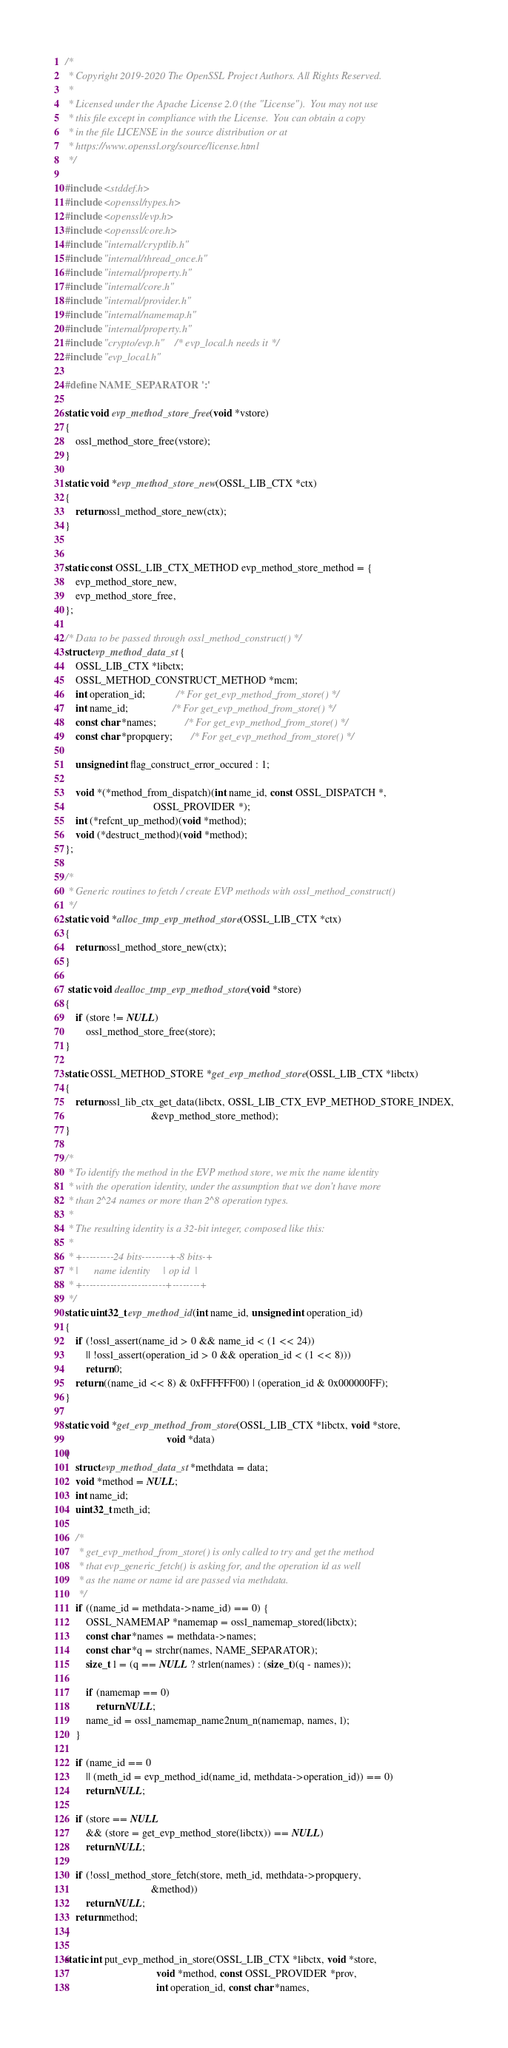Convert code to text. <code><loc_0><loc_0><loc_500><loc_500><_C_>/*
 * Copyright 2019-2020 The OpenSSL Project Authors. All Rights Reserved.
 *
 * Licensed under the Apache License 2.0 (the "License").  You may not use
 * this file except in compliance with the License.  You can obtain a copy
 * in the file LICENSE in the source distribution or at
 * https://www.openssl.org/source/license.html
 */

#include <stddef.h>
#include <openssl/types.h>
#include <openssl/evp.h>
#include <openssl/core.h>
#include "internal/cryptlib.h"
#include "internal/thread_once.h"
#include "internal/property.h"
#include "internal/core.h"
#include "internal/provider.h"
#include "internal/namemap.h"
#include "internal/property.h"
#include "crypto/evp.h"    /* evp_local.h needs it */
#include "evp_local.h"

#define NAME_SEPARATOR ':'

static void evp_method_store_free(void *vstore)
{
    ossl_method_store_free(vstore);
}

static void *evp_method_store_new(OSSL_LIB_CTX *ctx)
{
    return ossl_method_store_new(ctx);
}


static const OSSL_LIB_CTX_METHOD evp_method_store_method = {
    evp_method_store_new,
    evp_method_store_free,
};

/* Data to be passed through ossl_method_construct() */
struct evp_method_data_st {
    OSSL_LIB_CTX *libctx;
    OSSL_METHOD_CONSTRUCT_METHOD *mcm;
    int operation_id;            /* For get_evp_method_from_store() */
    int name_id;                 /* For get_evp_method_from_store() */
    const char *names;           /* For get_evp_method_from_store() */
    const char *propquery;       /* For get_evp_method_from_store() */

    unsigned int flag_construct_error_occured : 1;

    void *(*method_from_dispatch)(int name_id, const OSSL_DISPATCH *,
                                  OSSL_PROVIDER *);
    int (*refcnt_up_method)(void *method);
    void (*destruct_method)(void *method);
};

/*
 * Generic routines to fetch / create EVP methods with ossl_method_construct()
 */
static void *alloc_tmp_evp_method_store(OSSL_LIB_CTX *ctx)
{
    return ossl_method_store_new(ctx);
}

 static void dealloc_tmp_evp_method_store(void *store)
{
    if (store != NULL)
        ossl_method_store_free(store);
}

static OSSL_METHOD_STORE *get_evp_method_store(OSSL_LIB_CTX *libctx)
{
    return ossl_lib_ctx_get_data(libctx, OSSL_LIB_CTX_EVP_METHOD_STORE_INDEX,
                                 &evp_method_store_method);
}

/*
 * To identify the method in the EVP method store, we mix the name identity
 * with the operation identity, under the assumption that we don't have more
 * than 2^24 names or more than 2^8 operation types.
 *
 * The resulting identity is a 32-bit integer, composed like this:
 *
 * +---------24 bits--------+-8 bits-+
 * |      name identity     | op id  |
 * +------------------------+--------+
 */
static uint32_t evp_method_id(int name_id, unsigned int operation_id)
{
    if (!ossl_assert(name_id > 0 && name_id < (1 << 24))
        || !ossl_assert(operation_id > 0 && operation_id < (1 << 8)))
        return 0;
    return ((name_id << 8) & 0xFFFFFF00) | (operation_id & 0x000000FF);
}

static void *get_evp_method_from_store(OSSL_LIB_CTX *libctx, void *store,
                                       void *data)
{
    struct evp_method_data_st *methdata = data;
    void *method = NULL;
    int name_id;
    uint32_t meth_id;

    /*
     * get_evp_method_from_store() is only called to try and get the method
     * that evp_generic_fetch() is asking for, and the operation id as well
     * as the name or name id are passed via methdata.
     */
    if ((name_id = methdata->name_id) == 0) {
        OSSL_NAMEMAP *namemap = ossl_namemap_stored(libctx);
        const char *names = methdata->names;
        const char *q = strchr(names, NAME_SEPARATOR);
        size_t l = (q == NULL ? strlen(names) : (size_t)(q - names));

        if (namemap == 0)
            return NULL;
        name_id = ossl_namemap_name2num_n(namemap, names, l);
    }

    if (name_id == 0
        || (meth_id = evp_method_id(name_id, methdata->operation_id)) == 0)
        return NULL;

    if (store == NULL
        && (store = get_evp_method_store(libctx)) == NULL)
        return NULL;

    if (!ossl_method_store_fetch(store, meth_id, methdata->propquery,
                                 &method))
        return NULL;
    return method;
}

static int put_evp_method_in_store(OSSL_LIB_CTX *libctx, void *store,
                                   void *method, const OSSL_PROVIDER *prov,
                                   int operation_id, const char *names,</code> 